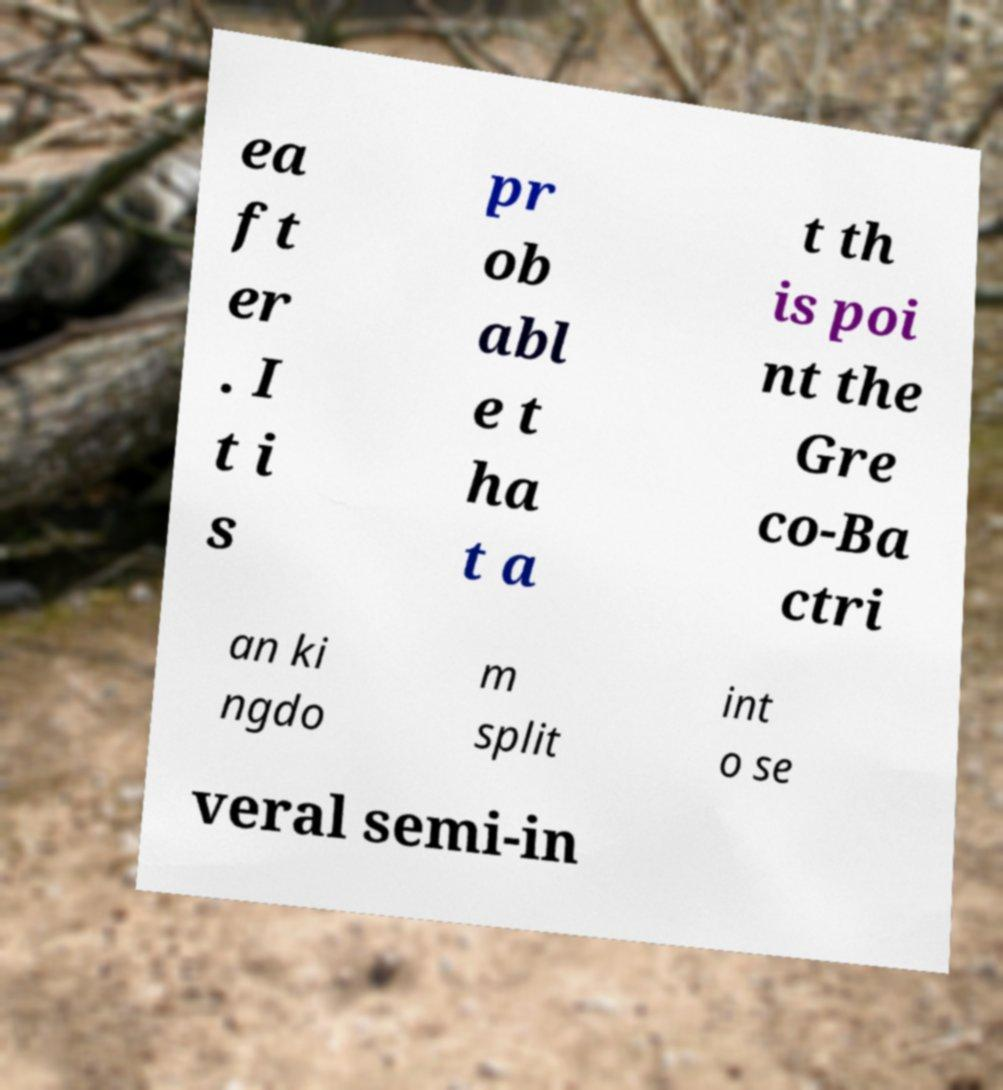There's text embedded in this image that I need extracted. Can you transcribe it verbatim? ea ft er . I t i s pr ob abl e t ha t a t th is poi nt the Gre co-Ba ctri an ki ngdo m split int o se veral semi-in 